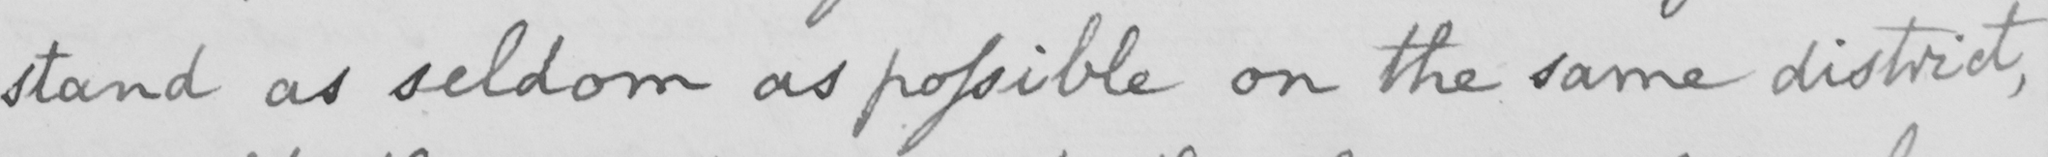Please transcribe the handwritten text in this image. stand as seldom as possible on the same district , 